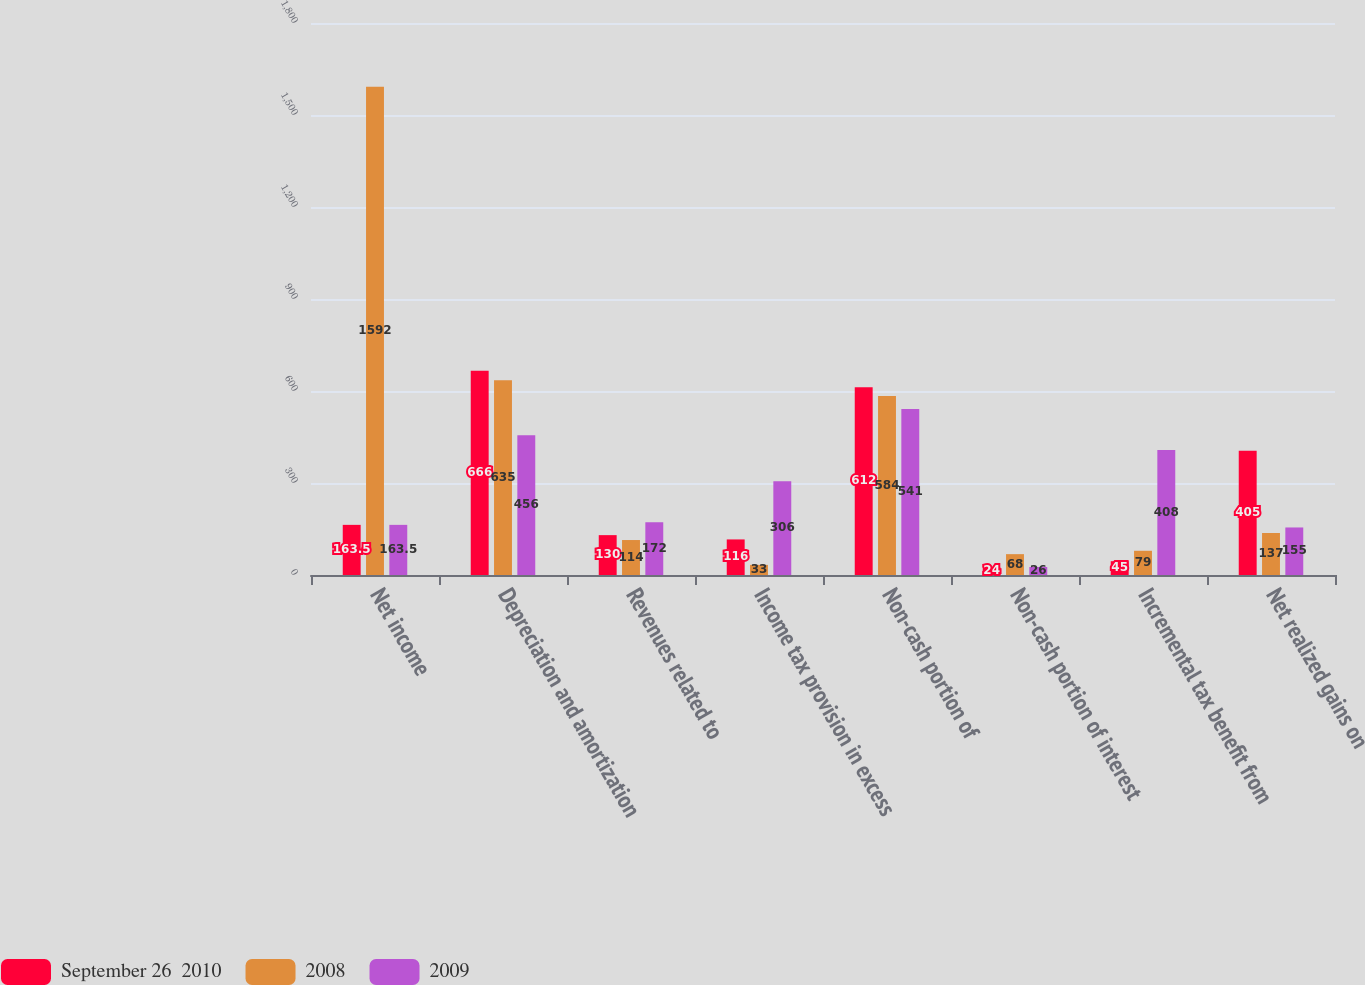Convert chart to OTSL. <chart><loc_0><loc_0><loc_500><loc_500><stacked_bar_chart><ecel><fcel>Net income<fcel>Depreciation and amortization<fcel>Revenues related to<fcel>Income tax provision in excess<fcel>Non-cash portion of<fcel>Non-cash portion of interest<fcel>Incremental tax benefit from<fcel>Net realized gains on<nl><fcel>September 26  2010<fcel>163.5<fcel>666<fcel>130<fcel>116<fcel>612<fcel>24<fcel>45<fcel>405<nl><fcel>2008<fcel>1592<fcel>635<fcel>114<fcel>33<fcel>584<fcel>68<fcel>79<fcel>137<nl><fcel>2009<fcel>163.5<fcel>456<fcel>172<fcel>306<fcel>541<fcel>26<fcel>408<fcel>155<nl></chart> 